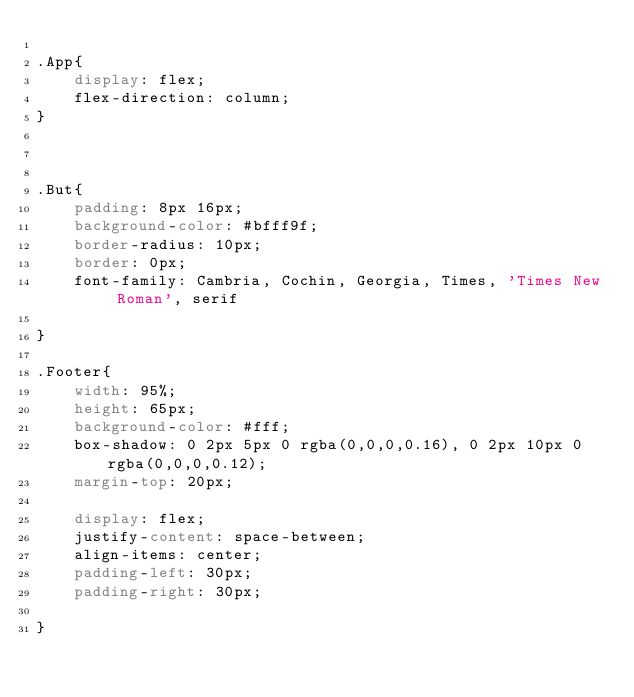Convert code to text. <code><loc_0><loc_0><loc_500><loc_500><_CSS_>
.App{
    display: flex;
    flex-direction: column; 
}



.But{
    padding: 8px 16px;
    background-color: #bfff9f;
    border-radius: 10px;
    border: 0px;
    font-family: Cambria, Cochin, Georgia, Times, 'Times New Roman', serif

}

.Footer{
    width: 95%;
    height: 65px;
    background-color: #fff;
    box-shadow: 0 2px 5px 0 rgba(0,0,0,0.16), 0 2px 10px 0 rgba(0,0,0,0.12);
    margin-top: 20px;

    display: flex;
    justify-content: space-between;
    align-items: center;
    padding-left: 30px;
    padding-right: 30px;
    
}</code> 